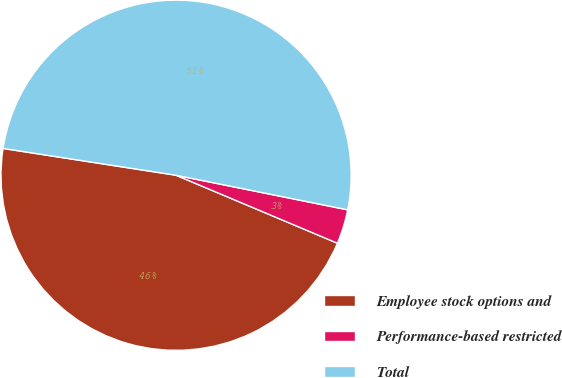Convert chart. <chart><loc_0><loc_0><loc_500><loc_500><pie_chart><fcel>Employee stock options and<fcel>Performance-based restricted<fcel>Total<nl><fcel>46.1%<fcel>3.18%<fcel>50.72%<nl></chart> 